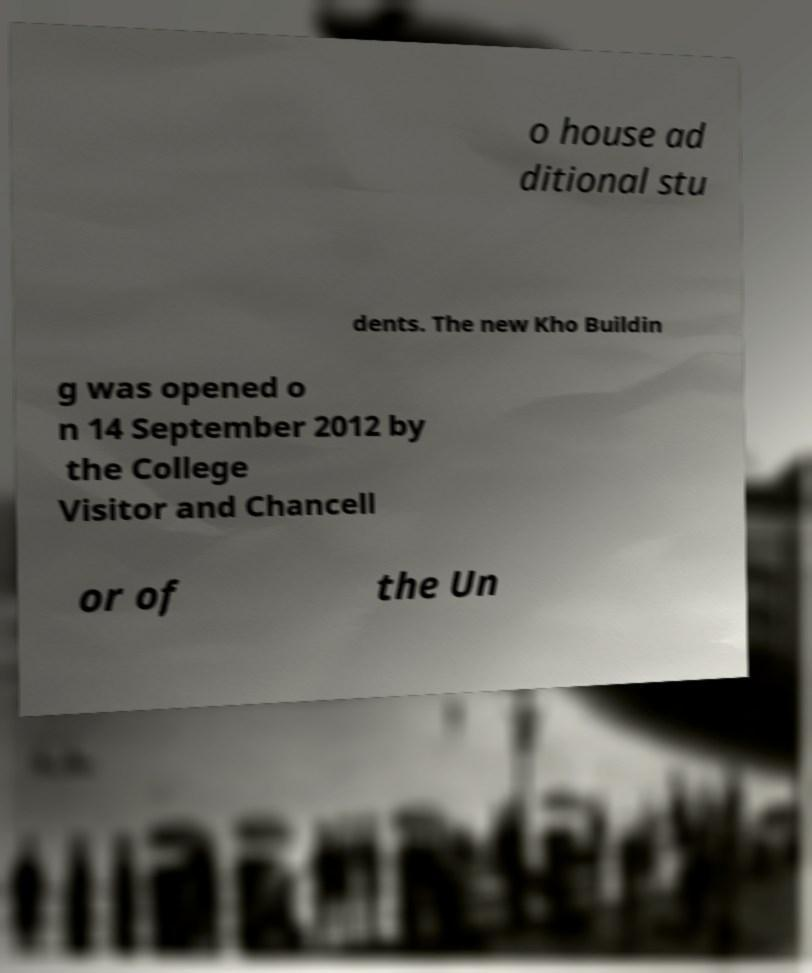I need the written content from this picture converted into text. Can you do that? o house ad ditional stu dents. The new Kho Buildin g was opened o n 14 September 2012 by the College Visitor and Chancell or of the Un 